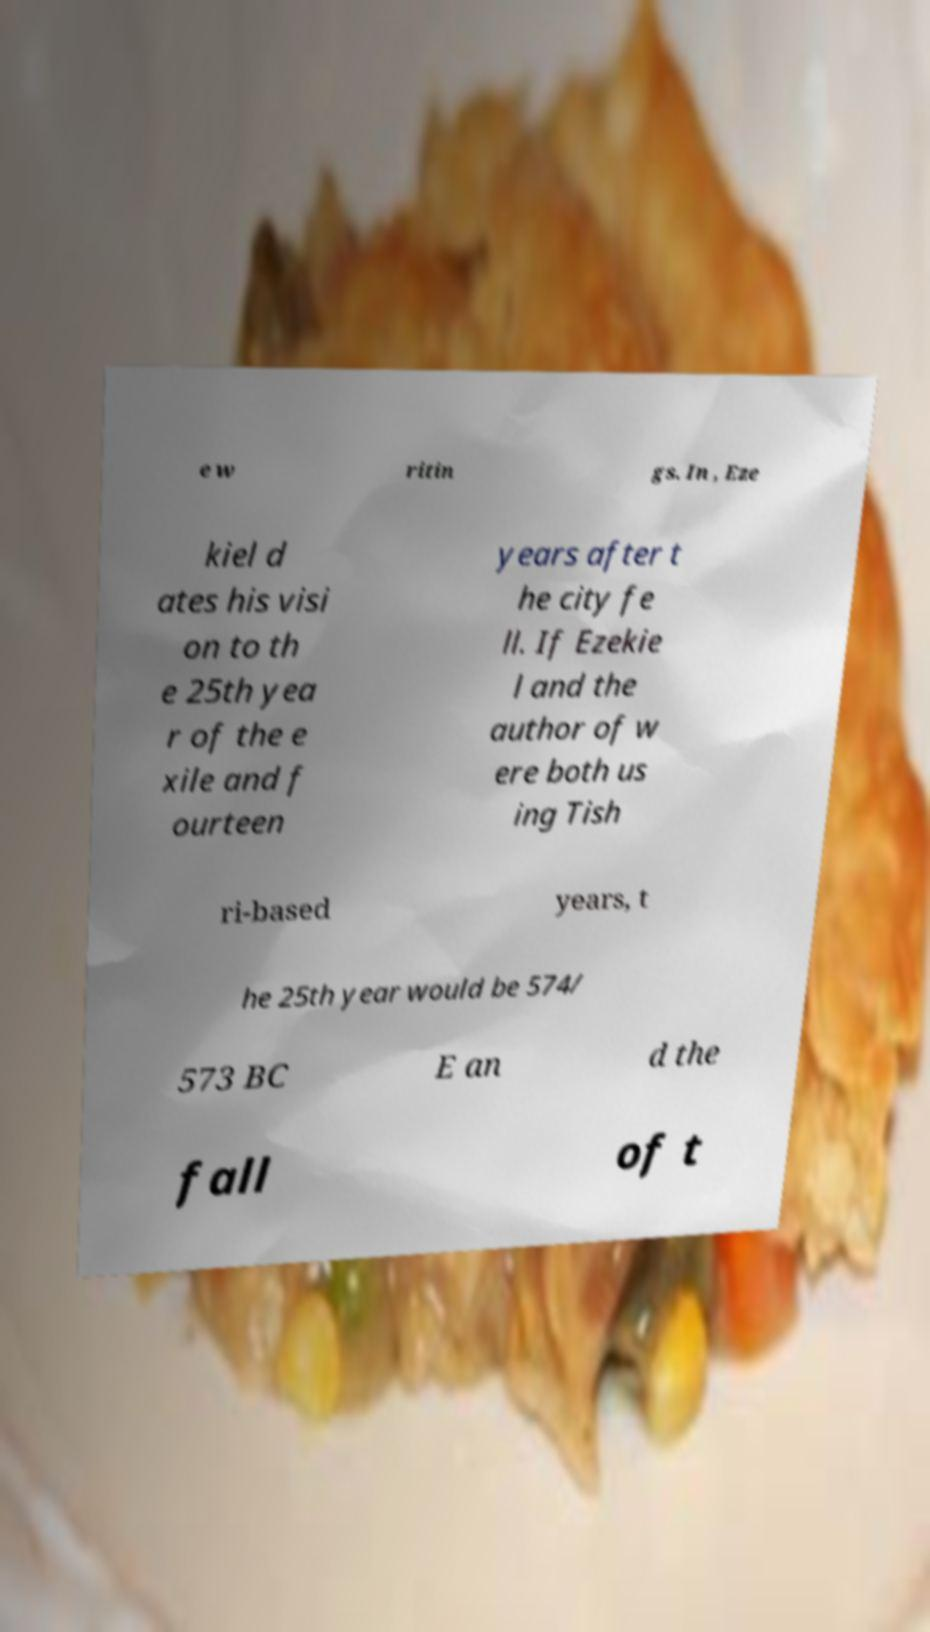Please read and relay the text visible in this image. What does it say? e w ritin gs. In , Eze kiel d ates his visi on to th e 25th yea r of the e xile and f ourteen years after t he city fe ll. If Ezekie l and the author of w ere both us ing Tish ri-based years, t he 25th year would be 574/ 573 BC E an d the fall of t 